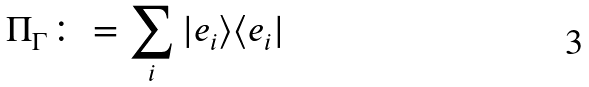Convert formula to latex. <formula><loc_0><loc_0><loc_500><loc_500>\Pi _ { \Gamma } \colon = \sum _ { i } | e _ { i } \rangle \langle e _ { i } |</formula> 